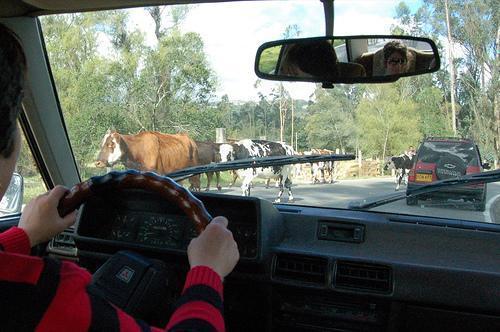How many cows can you see?
Give a very brief answer. 2. How many cars can be seen?
Give a very brief answer. 2. 